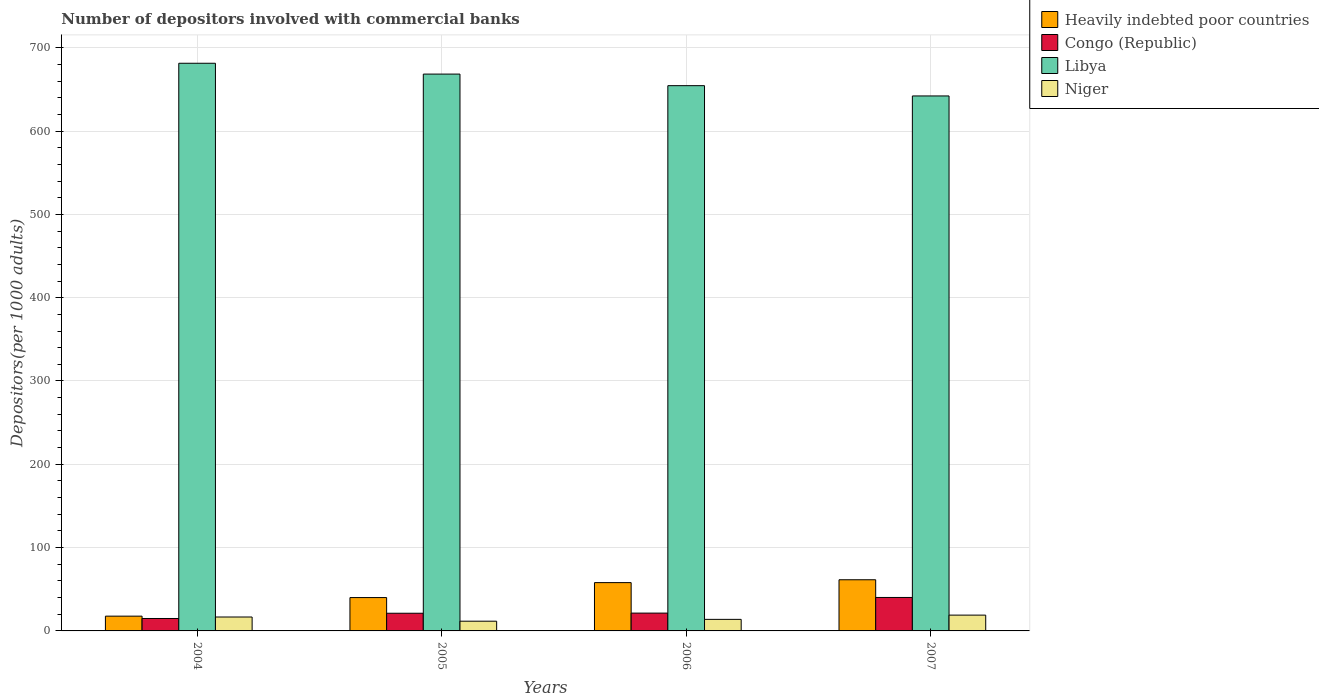How many different coloured bars are there?
Offer a terse response. 4. Are the number of bars on each tick of the X-axis equal?
Provide a short and direct response. Yes. In how many cases, is the number of bars for a given year not equal to the number of legend labels?
Your answer should be very brief. 0. What is the number of depositors involved with commercial banks in Niger in 2007?
Your answer should be very brief. 18.96. Across all years, what is the maximum number of depositors involved with commercial banks in Heavily indebted poor countries?
Make the answer very short. 61.41. Across all years, what is the minimum number of depositors involved with commercial banks in Libya?
Offer a terse response. 642.16. What is the total number of depositors involved with commercial banks in Niger in the graph?
Provide a short and direct response. 61.19. What is the difference between the number of depositors involved with commercial banks in Congo (Republic) in 2005 and that in 2007?
Offer a very short reply. -18.95. What is the difference between the number of depositors involved with commercial banks in Libya in 2006 and the number of depositors involved with commercial banks in Heavily indebted poor countries in 2004?
Offer a very short reply. 636.77. What is the average number of depositors involved with commercial banks in Congo (Republic) per year?
Give a very brief answer. 24.42. In the year 2007, what is the difference between the number of depositors involved with commercial banks in Congo (Republic) and number of depositors involved with commercial banks in Libya?
Your response must be concise. -601.99. What is the ratio of the number of depositors involved with commercial banks in Congo (Republic) in 2004 to that in 2007?
Your answer should be compact. 0.37. What is the difference between the highest and the second highest number of depositors involved with commercial banks in Congo (Republic)?
Make the answer very short. 18.77. What is the difference between the highest and the lowest number of depositors involved with commercial banks in Libya?
Provide a succinct answer. 39.23. In how many years, is the number of depositors involved with commercial banks in Heavily indebted poor countries greater than the average number of depositors involved with commercial banks in Heavily indebted poor countries taken over all years?
Offer a very short reply. 2. Is it the case that in every year, the sum of the number of depositors involved with commercial banks in Heavily indebted poor countries and number of depositors involved with commercial banks in Libya is greater than the sum of number of depositors involved with commercial banks in Niger and number of depositors involved with commercial banks in Congo (Republic)?
Keep it short and to the point. No. What does the 1st bar from the left in 2004 represents?
Give a very brief answer. Heavily indebted poor countries. What does the 2nd bar from the right in 2004 represents?
Your answer should be compact. Libya. Is it the case that in every year, the sum of the number of depositors involved with commercial banks in Heavily indebted poor countries and number of depositors involved with commercial banks in Niger is greater than the number of depositors involved with commercial banks in Libya?
Provide a succinct answer. No. How many bars are there?
Make the answer very short. 16. Are all the bars in the graph horizontal?
Keep it short and to the point. No. What is the difference between two consecutive major ticks on the Y-axis?
Provide a short and direct response. 100. Are the values on the major ticks of Y-axis written in scientific E-notation?
Offer a very short reply. No. Does the graph contain any zero values?
Your response must be concise. No. Does the graph contain grids?
Your response must be concise. Yes. Where does the legend appear in the graph?
Offer a terse response. Top right. How are the legend labels stacked?
Ensure brevity in your answer.  Vertical. What is the title of the graph?
Provide a succinct answer. Number of depositors involved with commercial banks. What is the label or title of the X-axis?
Provide a succinct answer. Years. What is the label or title of the Y-axis?
Make the answer very short. Depositors(per 1000 adults). What is the Depositors(per 1000 adults) in Heavily indebted poor countries in 2004?
Your response must be concise. 17.72. What is the Depositors(per 1000 adults) in Congo (Republic) in 2004?
Give a very brief answer. 14.92. What is the Depositors(per 1000 adults) in Libya in 2004?
Your answer should be compact. 681.39. What is the Depositors(per 1000 adults) of Niger in 2004?
Ensure brevity in your answer.  16.69. What is the Depositors(per 1000 adults) of Heavily indebted poor countries in 2005?
Offer a terse response. 40.04. What is the Depositors(per 1000 adults) of Congo (Republic) in 2005?
Offer a terse response. 21.22. What is the Depositors(per 1000 adults) of Libya in 2005?
Your response must be concise. 668.4. What is the Depositors(per 1000 adults) in Niger in 2005?
Give a very brief answer. 11.67. What is the Depositors(per 1000 adults) in Heavily indebted poor countries in 2006?
Your response must be concise. 57.99. What is the Depositors(per 1000 adults) of Congo (Republic) in 2006?
Your answer should be compact. 21.4. What is the Depositors(per 1000 adults) in Libya in 2006?
Offer a terse response. 654.49. What is the Depositors(per 1000 adults) of Niger in 2006?
Give a very brief answer. 13.87. What is the Depositors(per 1000 adults) in Heavily indebted poor countries in 2007?
Offer a terse response. 61.41. What is the Depositors(per 1000 adults) in Congo (Republic) in 2007?
Offer a terse response. 40.16. What is the Depositors(per 1000 adults) of Libya in 2007?
Your answer should be compact. 642.16. What is the Depositors(per 1000 adults) of Niger in 2007?
Your response must be concise. 18.96. Across all years, what is the maximum Depositors(per 1000 adults) of Heavily indebted poor countries?
Offer a terse response. 61.41. Across all years, what is the maximum Depositors(per 1000 adults) in Congo (Republic)?
Your answer should be compact. 40.16. Across all years, what is the maximum Depositors(per 1000 adults) of Libya?
Offer a terse response. 681.39. Across all years, what is the maximum Depositors(per 1000 adults) in Niger?
Your answer should be compact. 18.96. Across all years, what is the minimum Depositors(per 1000 adults) in Heavily indebted poor countries?
Offer a very short reply. 17.72. Across all years, what is the minimum Depositors(per 1000 adults) of Congo (Republic)?
Ensure brevity in your answer.  14.92. Across all years, what is the minimum Depositors(per 1000 adults) of Libya?
Keep it short and to the point. 642.16. Across all years, what is the minimum Depositors(per 1000 adults) of Niger?
Offer a very short reply. 11.67. What is the total Depositors(per 1000 adults) in Heavily indebted poor countries in the graph?
Offer a very short reply. 177.16. What is the total Depositors(per 1000 adults) in Congo (Republic) in the graph?
Ensure brevity in your answer.  97.7. What is the total Depositors(per 1000 adults) in Libya in the graph?
Make the answer very short. 2646.43. What is the total Depositors(per 1000 adults) of Niger in the graph?
Offer a terse response. 61.19. What is the difference between the Depositors(per 1000 adults) of Heavily indebted poor countries in 2004 and that in 2005?
Your response must be concise. -22.32. What is the difference between the Depositors(per 1000 adults) in Congo (Republic) in 2004 and that in 2005?
Offer a very short reply. -6.3. What is the difference between the Depositors(per 1000 adults) in Libya in 2004 and that in 2005?
Give a very brief answer. 12.99. What is the difference between the Depositors(per 1000 adults) of Niger in 2004 and that in 2005?
Your answer should be very brief. 5.02. What is the difference between the Depositors(per 1000 adults) of Heavily indebted poor countries in 2004 and that in 2006?
Keep it short and to the point. -40.27. What is the difference between the Depositors(per 1000 adults) of Congo (Republic) in 2004 and that in 2006?
Keep it short and to the point. -6.47. What is the difference between the Depositors(per 1000 adults) in Libya in 2004 and that in 2006?
Provide a succinct answer. 26.9. What is the difference between the Depositors(per 1000 adults) in Niger in 2004 and that in 2006?
Give a very brief answer. 2.82. What is the difference between the Depositors(per 1000 adults) in Heavily indebted poor countries in 2004 and that in 2007?
Offer a terse response. -43.68. What is the difference between the Depositors(per 1000 adults) in Congo (Republic) in 2004 and that in 2007?
Provide a succinct answer. -25.24. What is the difference between the Depositors(per 1000 adults) in Libya in 2004 and that in 2007?
Offer a very short reply. 39.23. What is the difference between the Depositors(per 1000 adults) of Niger in 2004 and that in 2007?
Offer a very short reply. -2.27. What is the difference between the Depositors(per 1000 adults) in Heavily indebted poor countries in 2005 and that in 2006?
Ensure brevity in your answer.  -17.95. What is the difference between the Depositors(per 1000 adults) in Congo (Republic) in 2005 and that in 2006?
Your answer should be very brief. -0.18. What is the difference between the Depositors(per 1000 adults) of Libya in 2005 and that in 2006?
Offer a terse response. 13.9. What is the difference between the Depositors(per 1000 adults) of Niger in 2005 and that in 2006?
Provide a succinct answer. -2.2. What is the difference between the Depositors(per 1000 adults) of Heavily indebted poor countries in 2005 and that in 2007?
Offer a terse response. -21.37. What is the difference between the Depositors(per 1000 adults) in Congo (Republic) in 2005 and that in 2007?
Offer a very short reply. -18.95. What is the difference between the Depositors(per 1000 adults) of Libya in 2005 and that in 2007?
Your response must be concise. 26.24. What is the difference between the Depositors(per 1000 adults) of Niger in 2005 and that in 2007?
Your answer should be very brief. -7.29. What is the difference between the Depositors(per 1000 adults) of Heavily indebted poor countries in 2006 and that in 2007?
Offer a terse response. -3.42. What is the difference between the Depositors(per 1000 adults) in Congo (Republic) in 2006 and that in 2007?
Ensure brevity in your answer.  -18.77. What is the difference between the Depositors(per 1000 adults) of Libya in 2006 and that in 2007?
Ensure brevity in your answer.  12.33. What is the difference between the Depositors(per 1000 adults) in Niger in 2006 and that in 2007?
Offer a terse response. -5.09. What is the difference between the Depositors(per 1000 adults) in Heavily indebted poor countries in 2004 and the Depositors(per 1000 adults) in Congo (Republic) in 2005?
Your answer should be compact. -3.49. What is the difference between the Depositors(per 1000 adults) of Heavily indebted poor countries in 2004 and the Depositors(per 1000 adults) of Libya in 2005?
Provide a succinct answer. -650.67. What is the difference between the Depositors(per 1000 adults) of Heavily indebted poor countries in 2004 and the Depositors(per 1000 adults) of Niger in 2005?
Your answer should be compact. 6.05. What is the difference between the Depositors(per 1000 adults) in Congo (Republic) in 2004 and the Depositors(per 1000 adults) in Libya in 2005?
Your response must be concise. -653.47. What is the difference between the Depositors(per 1000 adults) of Congo (Republic) in 2004 and the Depositors(per 1000 adults) of Niger in 2005?
Keep it short and to the point. 3.25. What is the difference between the Depositors(per 1000 adults) in Libya in 2004 and the Depositors(per 1000 adults) in Niger in 2005?
Your response must be concise. 669.72. What is the difference between the Depositors(per 1000 adults) of Heavily indebted poor countries in 2004 and the Depositors(per 1000 adults) of Congo (Republic) in 2006?
Your response must be concise. -3.67. What is the difference between the Depositors(per 1000 adults) of Heavily indebted poor countries in 2004 and the Depositors(per 1000 adults) of Libya in 2006?
Ensure brevity in your answer.  -636.77. What is the difference between the Depositors(per 1000 adults) in Heavily indebted poor countries in 2004 and the Depositors(per 1000 adults) in Niger in 2006?
Provide a short and direct response. 3.85. What is the difference between the Depositors(per 1000 adults) in Congo (Republic) in 2004 and the Depositors(per 1000 adults) in Libya in 2006?
Offer a very short reply. -639.57. What is the difference between the Depositors(per 1000 adults) in Congo (Republic) in 2004 and the Depositors(per 1000 adults) in Niger in 2006?
Provide a short and direct response. 1.05. What is the difference between the Depositors(per 1000 adults) of Libya in 2004 and the Depositors(per 1000 adults) of Niger in 2006?
Your response must be concise. 667.52. What is the difference between the Depositors(per 1000 adults) of Heavily indebted poor countries in 2004 and the Depositors(per 1000 adults) of Congo (Republic) in 2007?
Make the answer very short. -22.44. What is the difference between the Depositors(per 1000 adults) in Heavily indebted poor countries in 2004 and the Depositors(per 1000 adults) in Libya in 2007?
Make the answer very short. -624.43. What is the difference between the Depositors(per 1000 adults) in Heavily indebted poor countries in 2004 and the Depositors(per 1000 adults) in Niger in 2007?
Provide a succinct answer. -1.24. What is the difference between the Depositors(per 1000 adults) in Congo (Republic) in 2004 and the Depositors(per 1000 adults) in Libya in 2007?
Provide a succinct answer. -627.24. What is the difference between the Depositors(per 1000 adults) of Congo (Republic) in 2004 and the Depositors(per 1000 adults) of Niger in 2007?
Provide a succinct answer. -4.04. What is the difference between the Depositors(per 1000 adults) in Libya in 2004 and the Depositors(per 1000 adults) in Niger in 2007?
Your answer should be compact. 662.43. What is the difference between the Depositors(per 1000 adults) of Heavily indebted poor countries in 2005 and the Depositors(per 1000 adults) of Congo (Republic) in 2006?
Make the answer very short. 18.64. What is the difference between the Depositors(per 1000 adults) in Heavily indebted poor countries in 2005 and the Depositors(per 1000 adults) in Libya in 2006?
Offer a very short reply. -614.45. What is the difference between the Depositors(per 1000 adults) in Heavily indebted poor countries in 2005 and the Depositors(per 1000 adults) in Niger in 2006?
Offer a very short reply. 26.17. What is the difference between the Depositors(per 1000 adults) in Congo (Republic) in 2005 and the Depositors(per 1000 adults) in Libya in 2006?
Offer a terse response. -633.27. What is the difference between the Depositors(per 1000 adults) of Congo (Republic) in 2005 and the Depositors(per 1000 adults) of Niger in 2006?
Make the answer very short. 7.35. What is the difference between the Depositors(per 1000 adults) in Libya in 2005 and the Depositors(per 1000 adults) in Niger in 2006?
Make the answer very short. 654.52. What is the difference between the Depositors(per 1000 adults) of Heavily indebted poor countries in 2005 and the Depositors(per 1000 adults) of Congo (Republic) in 2007?
Your response must be concise. -0.12. What is the difference between the Depositors(per 1000 adults) of Heavily indebted poor countries in 2005 and the Depositors(per 1000 adults) of Libya in 2007?
Provide a succinct answer. -602.12. What is the difference between the Depositors(per 1000 adults) in Heavily indebted poor countries in 2005 and the Depositors(per 1000 adults) in Niger in 2007?
Make the answer very short. 21.08. What is the difference between the Depositors(per 1000 adults) in Congo (Republic) in 2005 and the Depositors(per 1000 adults) in Libya in 2007?
Your answer should be very brief. -620.94. What is the difference between the Depositors(per 1000 adults) in Congo (Republic) in 2005 and the Depositors(per 1000 adults) in Niger in 2007?
Give a very brief answer. 2.26. What is the difference between the Depositors(per 1000 adults) of Libya in 2005 and the Depositors(per 1000 adults) of Niger in 2007?
Ensure brevity in your answer.  649.43. What is the difference between the Depositors(per 1000 adults) of Heavily indebted poor countries in 2006 and the Depositors(per 1000 adults) of Congo (Republic) in 2007?
Offer a very short reply. 17.83. What is the difference between the Depositors(per 1000 adults) of Heavily indebted poor countries in 2006 and the Depositors(per 1000 adults) of Libya in 2007?
Your answer should be compact. -584.17. What is the difference between the Depositors(per 1000 adults) of Heavily indebted poor countries in 2006 and the Depositors(per 1000 adults) of Niger in 2007?
Make the answer very short. 39.03. What is the difference between the Depositors(per 1000 adults) in Congo (Republic) in 2006 and the Depositors(per 1000 adults) in Libya in 2007?
Your response must be concise. -620.76. What is the difference between the Depositors(per 1000 adults) in Congo (Republic) in 2006 and the Depositors(per 1000 adults) in Niger in 2007?
Provide a short and direct response. 2.43. What is the difference between the Depositors(per 1000 adults) in Libya in 2006 and the Depositors(per 1000 adults) in Niger in 2007?
Your response must be concise. 635.53. What is the average Depositors(per 1000 adults) of Heavily indebted poor countries per year?
Your answer should be very brief. 44.29. What is the average Depositors(per 1000 adults) in Congo (Republic) per year?
Offer a very short reply. 24.42. What is the average Depositors(per 1000 adults) in Libya per year?
Your answer should be compact. 661.61. What is the average Depositors(per 1000 adults) in Niger per year?
Provide a succinct answer. 15.3. In the year 2004, what is the difference between the Depositors(per 1000 adults) in Heavily indebted poor countries and Depositors(per 1000 adults) in Congo (Republic)?
Make the answer very short. 2.8. In the year 2004, what is the difference between the Depositors(per 1000 adults) of Heavily indebted poor countries and Depositors(per 1000 adults) of Libya?
Offer a very short reply. -663.66. In the year 2004, what is the difference between the Depositors(per 1000 adults) of Heavily indebted poor countries and Depositors(per 1000 adults) of Niger?
Offer a terse response. 1.03. In the year 2004, what is the difference between the Depositors(per 1000 adults) of Congo (Republic) and Depositors(per 1000 adults) of Libya?
Your response must be concise. -666.47. In the year 2004, what is the difference between the Depositors(per 1000 adults) in Congo (Republic) and Depositors(per 1000 adults) in Niger?
Provide a short and direct response. -1.77. In the year 2004, what is the difference between the Depositors(per 1000 adults) of Libya and Depositors(per 1000 adults) of Niger?
Make the answer very short. 664.7. In the year 2005, what is the difference between the Depositors(per 1000 adults) in Heavily indebted poor countries and Depositors(per 1000 adults) in Congo (Republic)?
Provide a short and direct response. 18.82. In the year 2005, what is the difference between the Depositors(per 1000 adults) in Heavily indebted poor countries and Depositors(per 1000 adults) in Libya?
Your response must be concise. -628.36. In the year 2005, what is the difference between the Depositors(per 1000 adults) of Heavily indebted poor countries and Depositors(per 1000 adults) of Niger?
Keep it short and to the point. 28.37. In the year 2005, what is the difference between the Depositors(per 1000 adults) of Congo (Republic) and Depositors(per 1000 adults) of Libya?
Your answer should be very brief. -647.18. In the year 2005, what is the difference between the Depositors(per 1000 adults) of Congo (Republic) and Depositors(per 1000 adults) of Niger?
Make the answer very short. 9.55. In the year 2005, what is the difference between the Depositors(per 1000 adults) in Libya and Depositors(per 1000 adults) in Niger?
Give a very brief answer. 656.73. In the year 2006, what is the difference between the Depositors(per 1000 adults) of Heavily indebted poor countries and Depositors(per 1000 adults) of Congo (Republic)?
Provide a succinct answer. 36.6. In the year 2006, what is the difference between the Depositors(per 1000 adults) of Heavily indebted poor countries and Depositors(per 1000 adults) of Libya?
Make the answer very short. -596.5. In the year 2006, what is the difference between the Depositors(per 1000 adults) of Heavily indebted poor countries and Depositors(per 1000 adults) of Niger?
Ensure brevity in your answer.  44.12. In the year 2006, what is the difference between the Depositors(per 1000 adults) of Congo (Republic) and Depositors(per 1000 adults) of Libya?
Your answer should be compact. -633.1. In the year 2006, what is the difference between the Depositors(per 1000 adults) in Congo (Republic) and Depositors(per 1000 adults) in Niger?
Keep it short and to the point. 7.52. In the year 2006, what is the difference between the Depositors(per 1000 adults) in Libya and Depositors(per 1000 adults) in Niger?
Provide a short and direct response. 640.62. In the year 2007, what is the difference between the Depositors(per 1000 adults) in Heavily indebted poor countries and Depositors(per 1000 adults) in Congo (Republic)?
Provide a short and direct response. 21.24. In the year 2007, what is the difference between the Depositors(per 1000 adults) in Heavily indebted poor countries and Depositors(per 1000 adults) in Libya?
Make the answer very short. -580.75. In the year 2007, what is the difference between the Depositors(per 1000 adults) in Heavily indebted poor countries and Depositors(per 1000 adults) in Niger?
Keep it short and to the point. 42.45. In the year 2007, what is the difference between the Depositors(per 1000 adults) in Congo (Republic) and Depositors(per 1000 adults) in Libya?
Provide a succinct answer. -601.99. In the year 2007, what is the difference between the Depositors(per 1000 adults) in Congo (Republic) and Depositors(per 1000 adults) in Niger?
Ensure brevity in your answer.  21.2. In the year 2007, what is the difference between the Depositors(per 1000 adults) of Libya and Depositors(per 1000 adults) of Niger?
Make the answer very short. 623.2. What is the ratio of the Depositors(per 1000 adults) of Heavily indebted poor countries in 2004 to that in 2005?
Provide a succinct answer. 0.44. What is the ratio of the Depositors(per 1000 adults) in Congo (Republic) in 2004 to that in 2005?
Your response must be concise. 0.7. What is the ratio of the Depositors(per 1000 adults) of Libya in 2004 to that in 2005?
Offer a very short reply. 1.02. What is the ratio of the Depositors(per 1000 adults) in Niger in 2004 to that in 2005?
Keep it short and to the point. 1.43. What is the ratio of the Depositors(per 1000 adults) of Heavily indebted poor countries in 2004 to that in 2006?
Your answer should be very brief. 0.31. What is the ratio of the Depositors(per 1000 adults) of Congo (Republic) in 2004 to that in 2006?
Your response must be concise. 0.7. What is the ratio of the Depositors(per 1000 adults) of Libya in 2004 to that in 2006?
Keep it short and to the point. 1.04. What is the ratio of the Depositors(per 1000 adults) in Niger in 2004 to that in 2006?
Keep it short and to the point. 1.2. What is the ratio of the Depositors(per 1000 adults) in Heavily indebted poor countries in 2004 to that in 2007?
Your answer should be very brief. 0.29. What is the ratio of the Depositors(per 1000 adults) of Congo (Republic) in 2004 to that in 2007?
Keep it short and to the point. 0.37. What is the ratio of the Depositors(per 1000 adults) of Libya in 2004 to that in 2007?
Your answer should be very brief. 1.06. What is the ratio of the Depositors(per 1000 adults) of Niger in 2004 to that in 2007?
Your answer should be compact. 0.88. What is the ratio of the Depositors(per 1000 adults) in Heavily indebted poor countries in 2005 to that in 2006?
Offer a very short reply. 0.69. What is the ratio of the Depositors(per 1000 adults) in Libya in 2005 to that in 2006?
Offer a terse response. 1.02. What is the ratio of the Depositors(per 1000 adults) of Niger in 2005 to that in 2006?
Provide a succinct answer. 0.84. What is the ratio of the Depositors(per 1000 adults) of Heavily indebted poor countries in 2005 to that in 2007?
Make the answer very short. 0.65. What is the ratio of the Depositors(per 1000 adults) in Congo (Republic) in 2005 to that in 2007?
Give a very brief answer. 0.53. What is the ratio of the Depositors(per 1000 adults) in Libya in 2005 to that in 2007?
Give a very brief answer. 1.04. What is the ratio of the Depositors(per 1000 adults) of Niger in 2005 to that in 2007?
Ensure brevity in your answer.  0.62. What is the ratio of the Depositors(per 1000 adults) in Heavily indebted poor countries in 2006 to that in 2007?
Offer a very short reply. 0.94. What is the ratio of the Depositors(per 1000 adults) of Congo (Republic) in 2006 to that in 2007?
Keep it short and to the point. 0.53. What is the ratio of the Depositors(per 1000 adults) in Libya in 2006 to that in 2007?
Make the answer very short. 1.02. What is the ratio of the Depositors(per 1000 adults) in Niger in 2006 to that in 2007?
Provide a short and direct response. 0.73. What is the difference between the highest and the second highest Depositors(per 1000 adults) of Heavily indebted poor countries?
Your response must be concise. 3.42. What is the difference between the highest and the second highest Depositors(per 1000 adults) in Congo (Republic)?
Offer a terse response. 18.77. What is the difference between the highest and the second highest Depositors(per 1000 adults) of Libya?
Keep it short and to the point. 12.99. What is the difference between the highest and the second highest Depositors(per 1000 adults) of Niger?
Provide a short and direct response. 2.27. What is the difference between the highest and the lowest Depositors(per 1000 adults) of Heavily indebted poor countries?
Keep it short and to the point. 43.68. What is the difference between the highest and the lowest Depositors(per 1000 adults) of Congo (Republic)?
Provide a succinct answer. 25.24. What is the difference between the highest and the lowest Depositors(per 1000 adults) of Libya?
Give a very brief answer. 39.23. What is the difference between the highest and the lowest Depositors(per 1000 adults) in Niger?
Your answer should be compact. 7.29. 